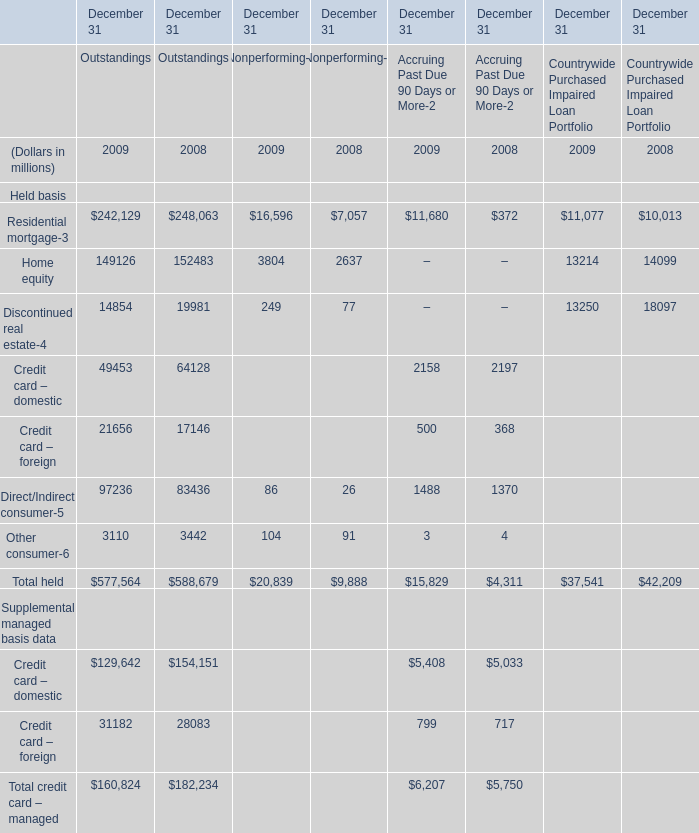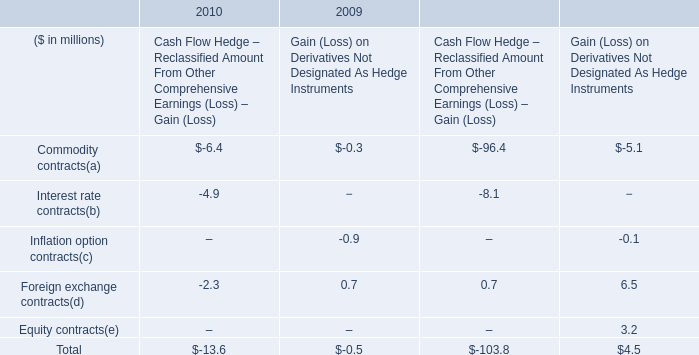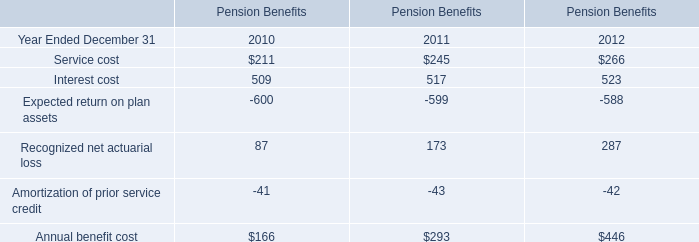What's the total amount of the Residential mortgage and Home equity of Outstandings in the years where Home equity of Outstandings is greater than 150000? (in million) 
Computations: (248063 + 152483)
Answer: 400546.0. 